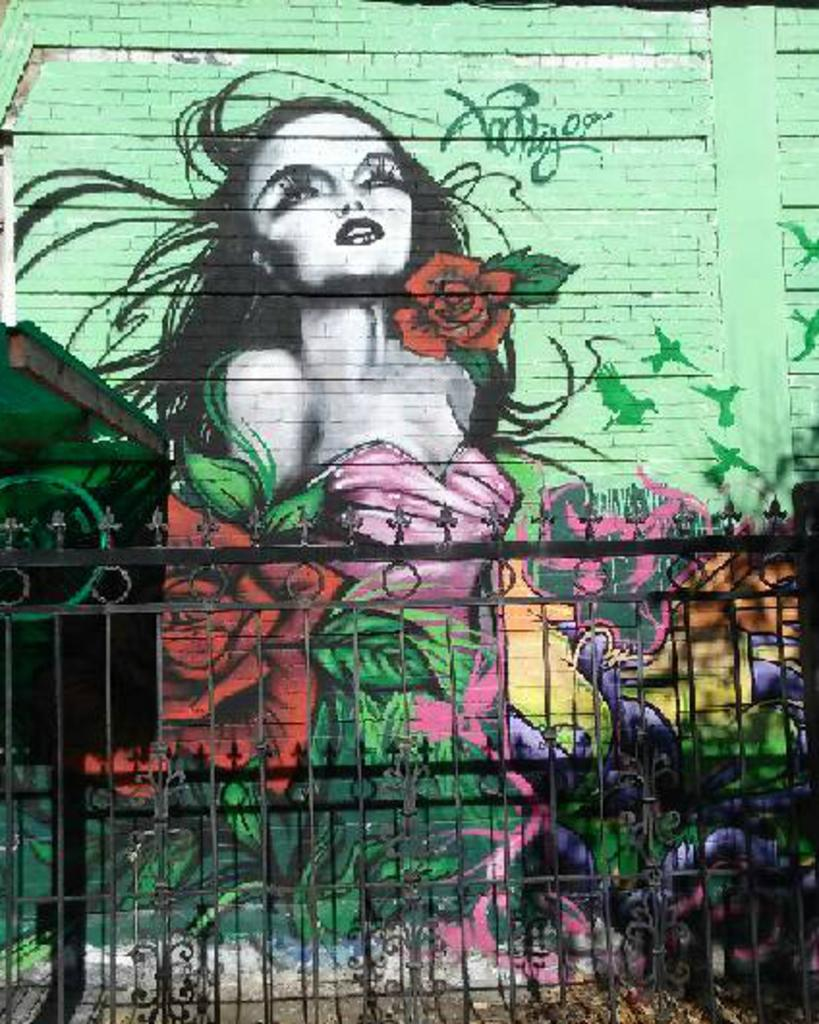What type of barrier is visible in the image? There is a fence in the image. What is located behind the fence? There is a wall behind the fence. What feature can be seen on the wall? The wall has a window. What type of artwork is present on the wall? There is a picture of a woman on the wall, and there are flower pictures painted on the wall. How many dimes can be seen on the wall in the image? There are no dimes visible on the wall in the image. Is there a bear standing next to the fence in the image? There is no bear present in the image. 